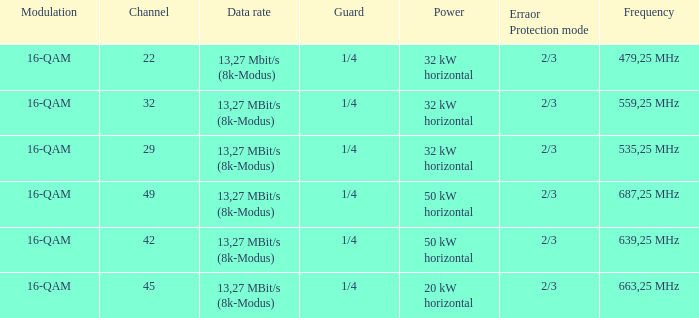On channel 32, when the power is 32 kw in horizontal direction, what is the frequency? 559,25 MHz. 